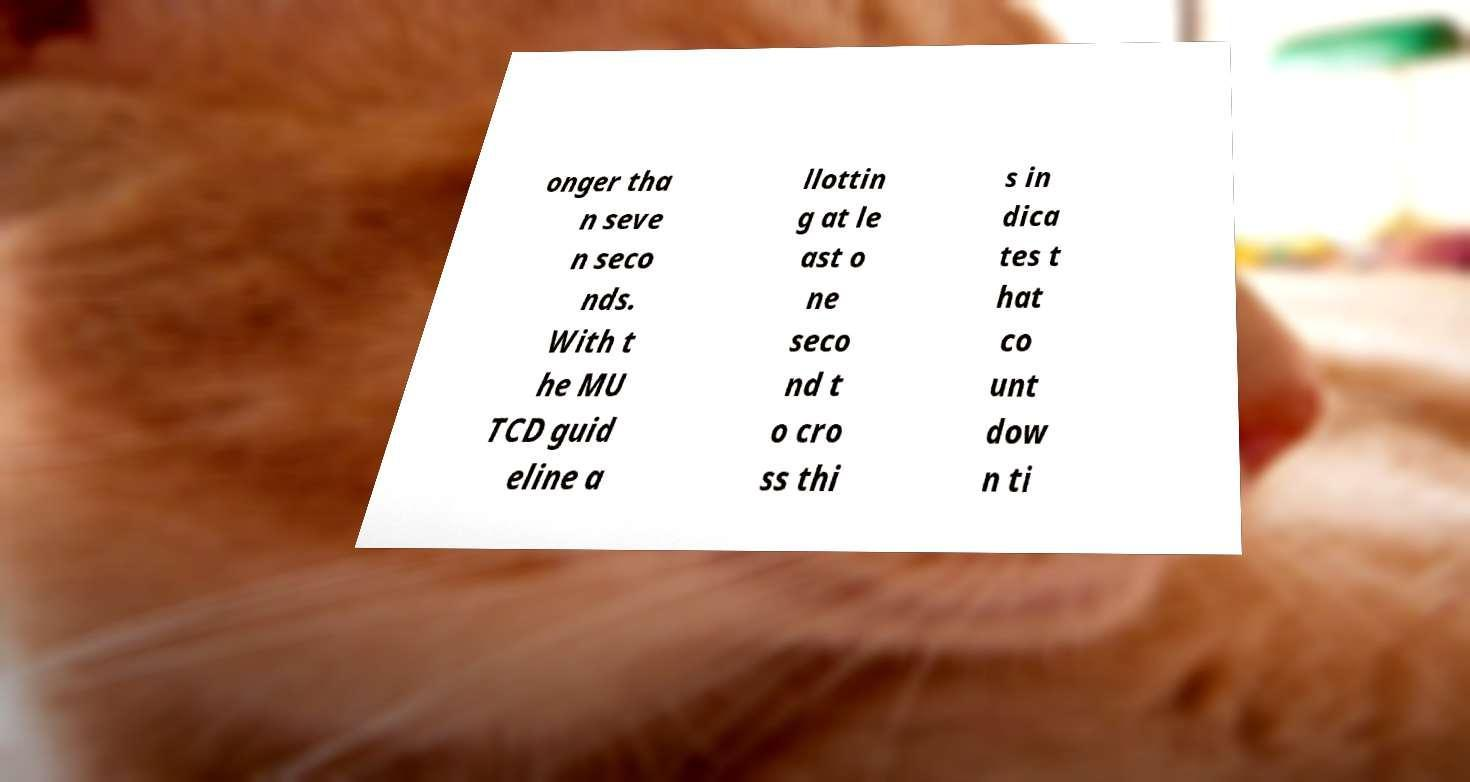Please identify and transcribe the text found in this image. onger tha n seve n seco nds. With t he MU TCD guid eline a llottin g at le ast o ne seco nd t o cro ss thi s in dica tes t hat co unt dow n ti 